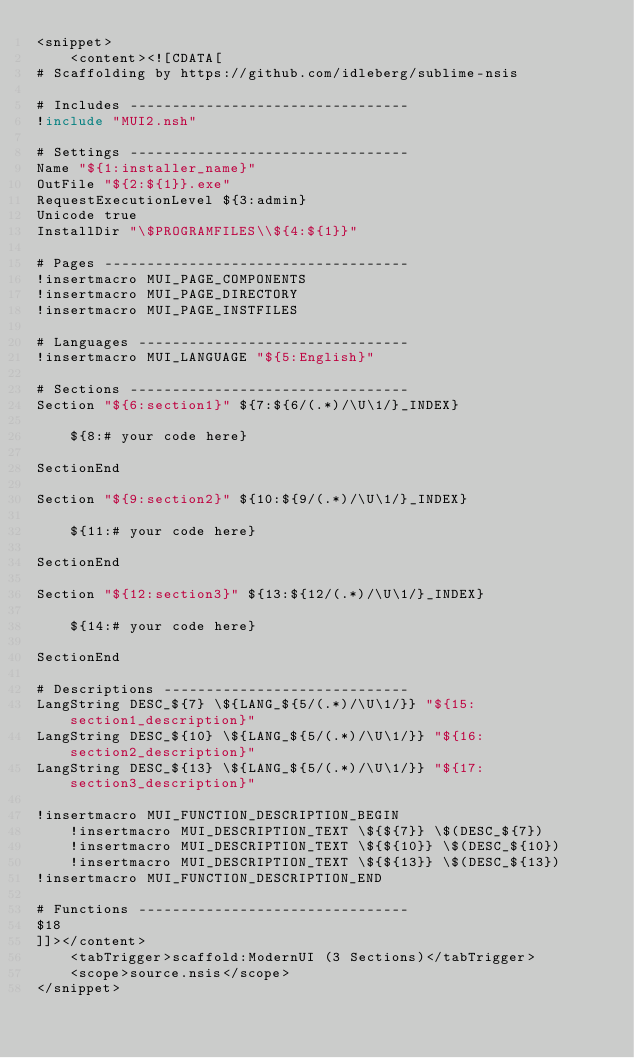<code> <loc_0><loc_0><loc_500><loc_500><_XML_><snippet>
	<content><![CDATA[
# Scaffolding by https://github.com/idleberg/sublime-nsis

# Includes ---------------------------------
!include "MUI2.nsh"

# Settings ---------------------------------
Name "${1:installer_name}"
OutFile "${2:${1}}.exe"
RequestExecutionLevel ${3:admin}
Unicode true
InstallDir "\$PROGRAMFILES\\${4:${1}}"

# Pages ------------------------------------
!insertmacro MUI_PAGE_COMPONENTS
!insertmacro MUI_PAGE_DIRECTORY
!insertmacro MUI_PAGE_INSTFILES

# Languages --------------------------------
!insertmacro MUI_LANGUAGE "${5:English}"

# Sections ---------------------------------
Section "${6:section1}" ${7:${6/(.*)/\U\1/}_INDEX}

	${8:# your code here}

SectionEnd

Section "${9:section2}" ${10:${9/(.*)/\U\1/}_INDEX}

	${11:# your code here}

SectionEnd

Section "${12:section3}" ${13:${12/(.*)/\U\1/}_INDEX}

	${14:# your code here}

SectionEnd

# Descriptions -----------------------------
LangString DESC_${7} \${LANG_${5/(.*)/\U\1/}} "${15:section1_description}"
LangString DESC_${10} \${LANG_${5/(.*)/\U\1/}} "${16:section2_description}"
LangString DESC_${13} \${LANG_${5/(.*)/\U\1/}} "${17:section3_description}"

!insertmacro MUI_FUNCTION_DESCRIPTION_BEGIN
	!insertmacro MUI_DESCRIPTION_TEXT \${${7}} \$(DESC_${7})
	!insertmacro MUI_DESCRIPTION_TEXT \${${10}} \$(DESC_${10})
	!insertmacro MUI_DESCRIPTION_TEXT \${${13}} \$(DESC_${13})
!insertmacro MUI_FUNCTION_DESCRIPTION_END

# Functions --------------------------------
$18
]]></content>
	<tabTrigger>scaffold:ModernUI (3 Sections)</tabTrigger>
	<scope>source.nsis</scope>
</snippet></code> 